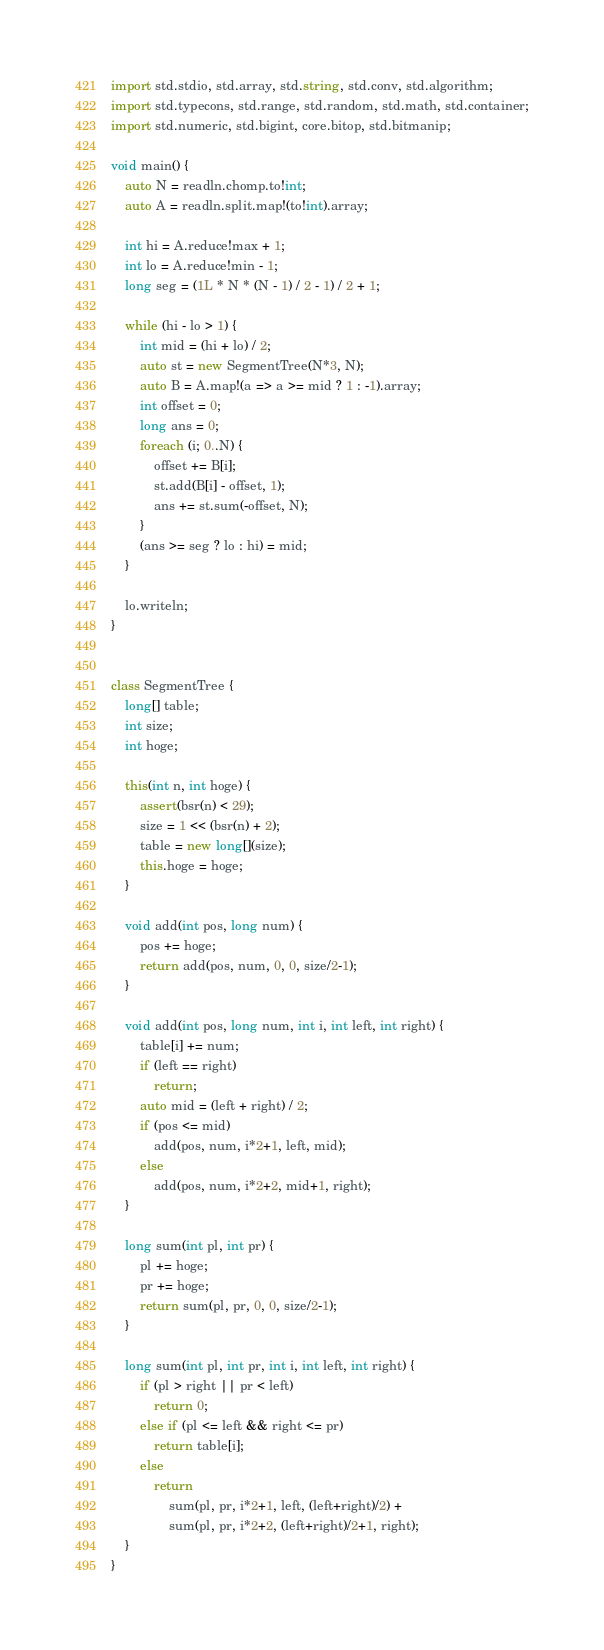<code> <loc_0><loc_0><loc_500><loc_500><_D_>import std.stdio, std.array, std.string, std.conv, std.algorithm;
import std.typecons, std.range, std.random, std.math, std.container;
import std.numeric, std.bigint, core.bitop, std.bitmanip;

void main() {
    auto N = readln.chomp.to!int;
    auto A = readln.split.map!(to!int).array;

    int hi = A.reduce!max + 1;
    int lo = A.reduce!min - 1;
    long seg = (1L * N * (N - 1) / 2 - 1) / 2 + 1;

    while (hi - lo > 1) {
        int mid = (hi + lo) / 2;
        auto st = new SegmentTree(N*3, N);
        auto B = A.map!(a => a >= mid ? 1 : -1).array;
        int offset = 0;
        long ans = 0;
        foreach (i; 0..N) {
            offset += B[i];
            st.add(B[i] - offset, 1);
            ans += st.sum(-offset, N);
        }
        (ans >= seg ? lo : hi) = mid;
    }

    lo.writeln;
}


class SegmentTree {
    long[] table;
    int size;
    int hoge;

    this(int n, int hoge) {
        assert(bsr(n) < 29);
        size = 1 << (bsr(n) + 2);
        table = new long[](size);
        this.hoge = hoge;
    }

    void add(int pos, long num) {
        pos += hoge;
        return add(pos, num, 0, 0, size/2-1);
    }

    void add(int pos, long num, int i, int left, int right) {
        table[i] += num;
        if (left == right)
            return;
        auto mid = (left + right) / 2;
        if (pos <= mid)
            add(pos, num, i*2+1, left, mid);
        else
            add(pos, num, i*2+2, mid+1, right);
    }

    long sum(int pl, int pr) {
        pl += hoge;
        pr += hoge;
        return sum(pl, pr, 0, 0, size/2-1);
    }

    long sum(int pl, int pr, int i, int left, int right) {
        if (pl > right || pr < left)
            return 0;
        else if (pl <= left && right <= pr)
            return table[i];
        else
            return
                sum(pl, pr, i*2+1, left, (left+right)/2) +
                sum(pl, pr, i*2+2, (left+right)/2+1, right);
    }
}
</code> 